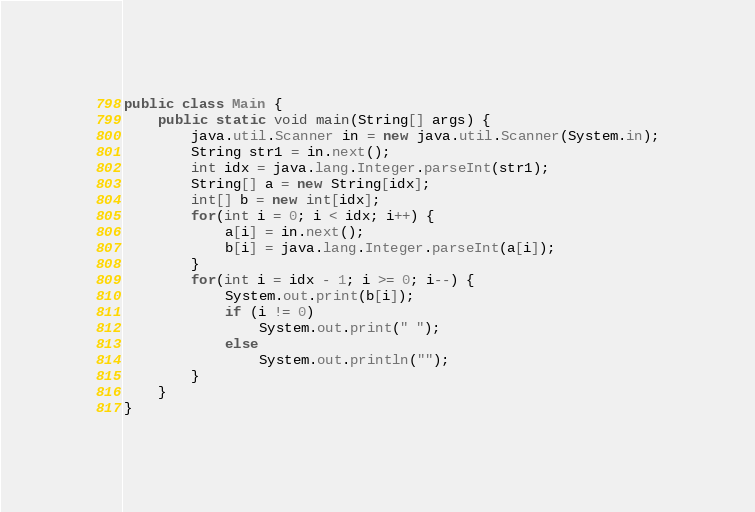<code> <loc_0><loc_0><loc_500><loc_500><_Java_>public class Main {
	public static void main(String[] args) {
		java.util.Scanner in = new java.util.Scanner(System.in);
		String str1 = in.next();
		int idx = java.lang.Integer.parseInt(str1);
		String[] a = new String[idx];
		int[] b = new int[idx];
		for(int i = 0; i < idx; i++) {
			a[i] = in.next();
			b[i] = java.lang.Integer.parseInt(a[i]);
		}
		for(int i = idx - 1; i >= 0; i--) {
			System.out.print(b[i]);
			if (i != 0)
				System.out.print(" ");
			else
				System.out.println("");
		}
	}
}</code> 